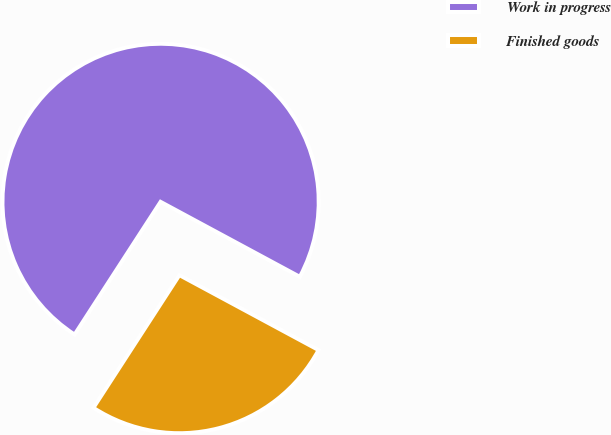Convert chart to OTSL. <chart><loc_0><loc_0><loc_500><loc_500><pie_chart><fcel>Work in progress<fcel>Finished goods<nl><fcel>73.71%<fcel>26.29%<nl></chart> 